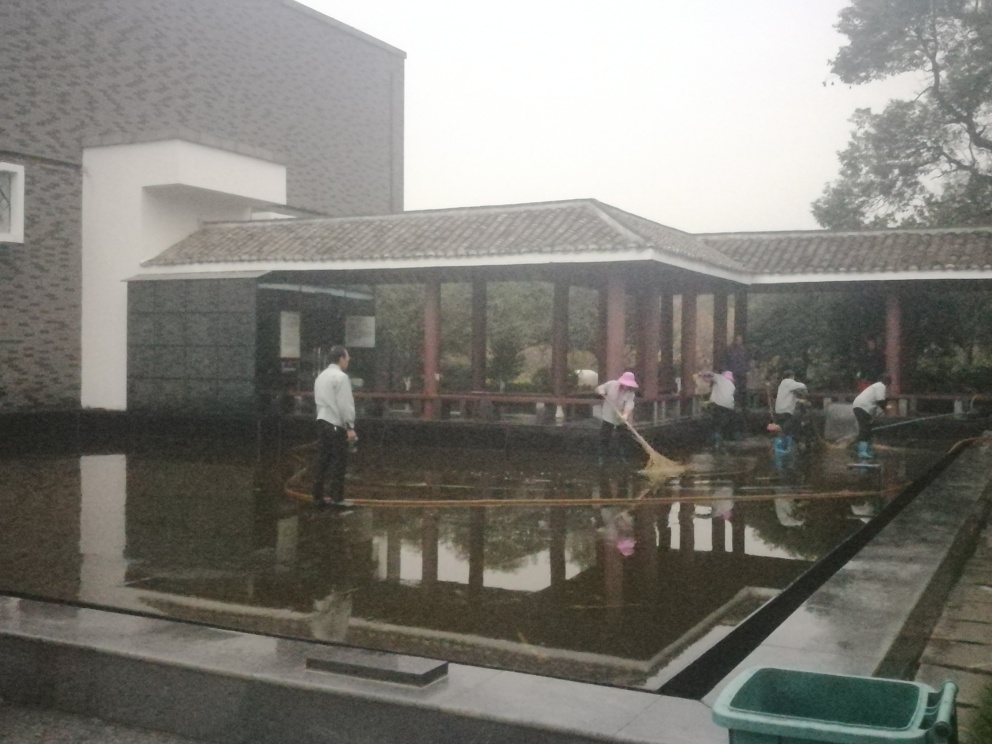What does the architecture in the image tell us about the location? The architecture, showing elements of East Asian design such as the tiled pagoda-like pavilion and the clean, minimal lines of the surrounding buildings, hints at a location that may be influenced by traditional East Asian, possibly Chinese, architectural styles. Can you infer the weather conditions at the time this image was taken? The overcast sky and wet surfaces suggest that the photo was taken on a rainy day, which may have added to the necessity for the cleaning activity being undertaken, as rain can wash debris into ponds and uncovered water features. 